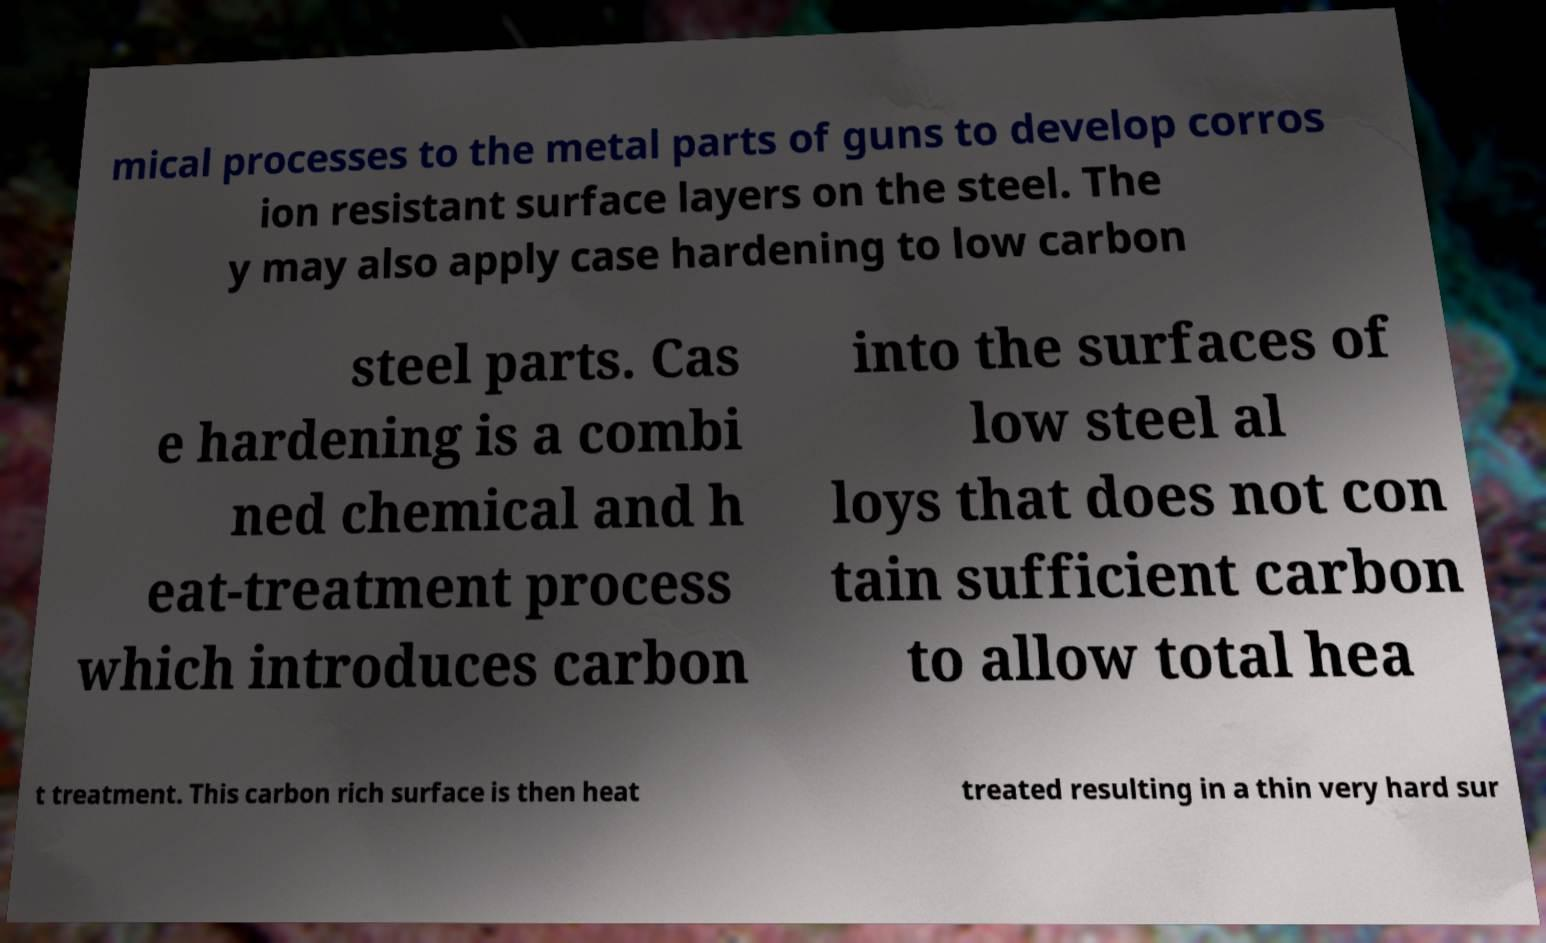Please identify and transcribe the text found in this image. mical processes to the metal parts of guns to develop corros ion resistant surface layers on the steel. The y may also apply case hardening to low carbon steel parts. Cas e hardening is a combi ned chemical and h eat-treatment process which introduces carbon into the surfaces of low steel al loys that does not con tain sufficient carbon to allow total hea t treatment. This carbon rich surface is then heat treated resulting in a thin very hard sur 